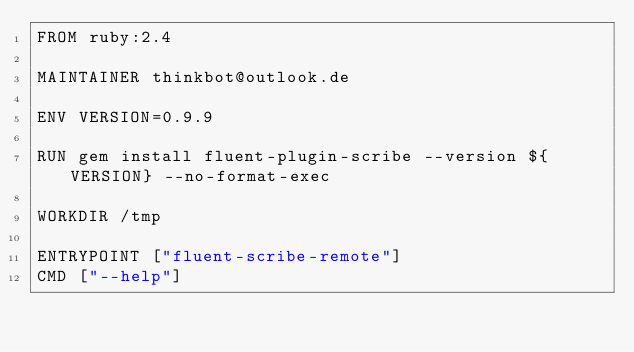<code> <loc_0><loc_0><loc_500><loc_500><_Dockerfile_>FROM ruby:2.4

MAINTAINER thinkbot@outlook.de

ENV VERSION=0.9.9

RUN gem install fluent-plugin-scribe --version ${VERSION} --no-format-exec

WORKDIR /tmp

ENTRYPOINT ["fluent-scribe-remote"]
CMD ["--help"]
</code> 